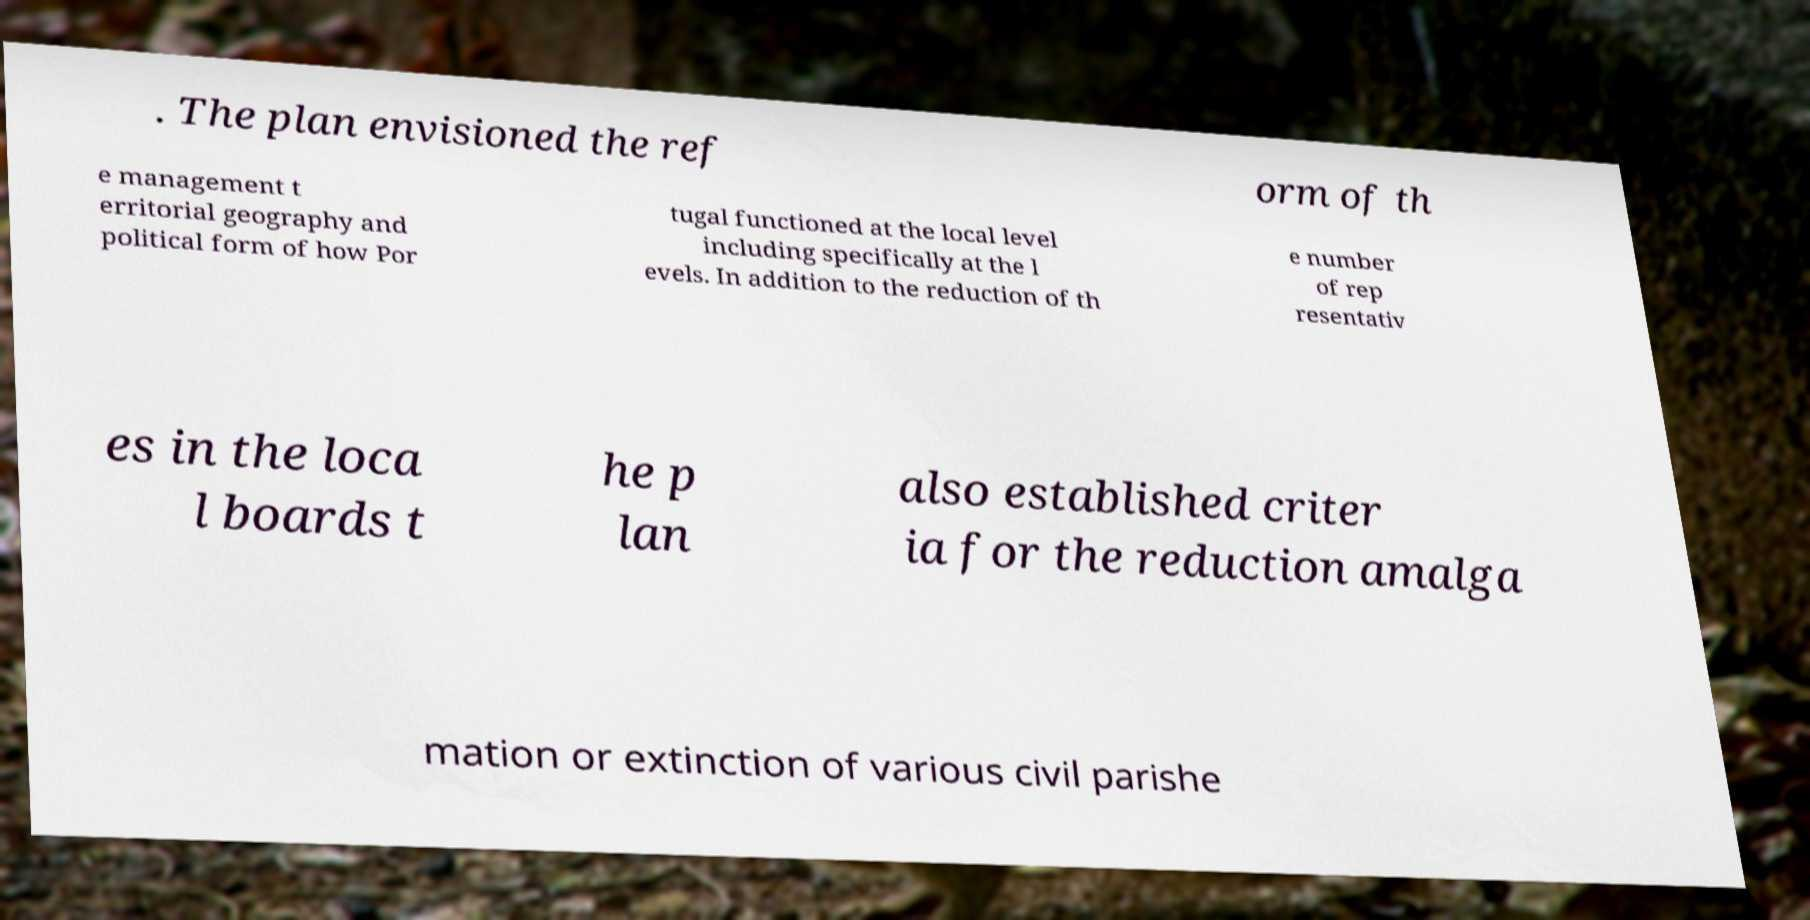I need the written content from this picture converted into text. Can you do that? . The plan envisioned the ref orm of th e management t erritorial geography and political form of how Por tugal functioned at the local level including specifically at the l evels. In addition to the reduction of th e number of rep resentativ es in the loca l boards t he p lan also established criter ia for the reduction amalga mation or extinction of various civil parishe 